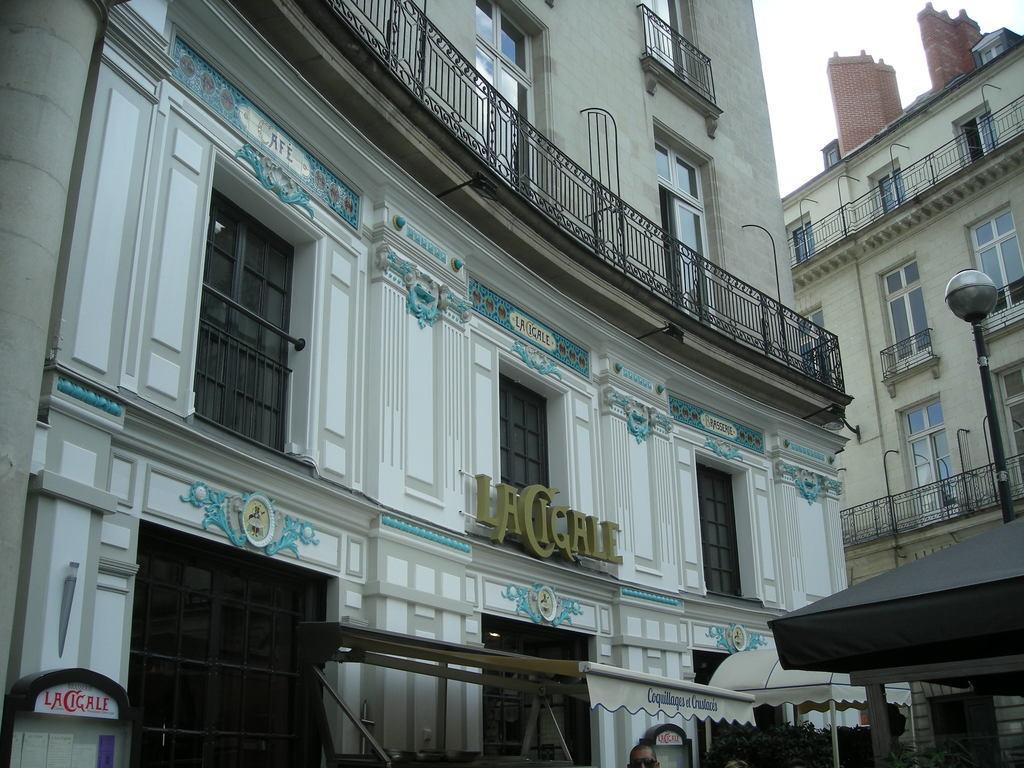How would you summarize this image in a sentence or two? In this image we can see buildings with glass windows. At the bottom of the image, we can see people and plants. There is the sky in the right top of the image. 